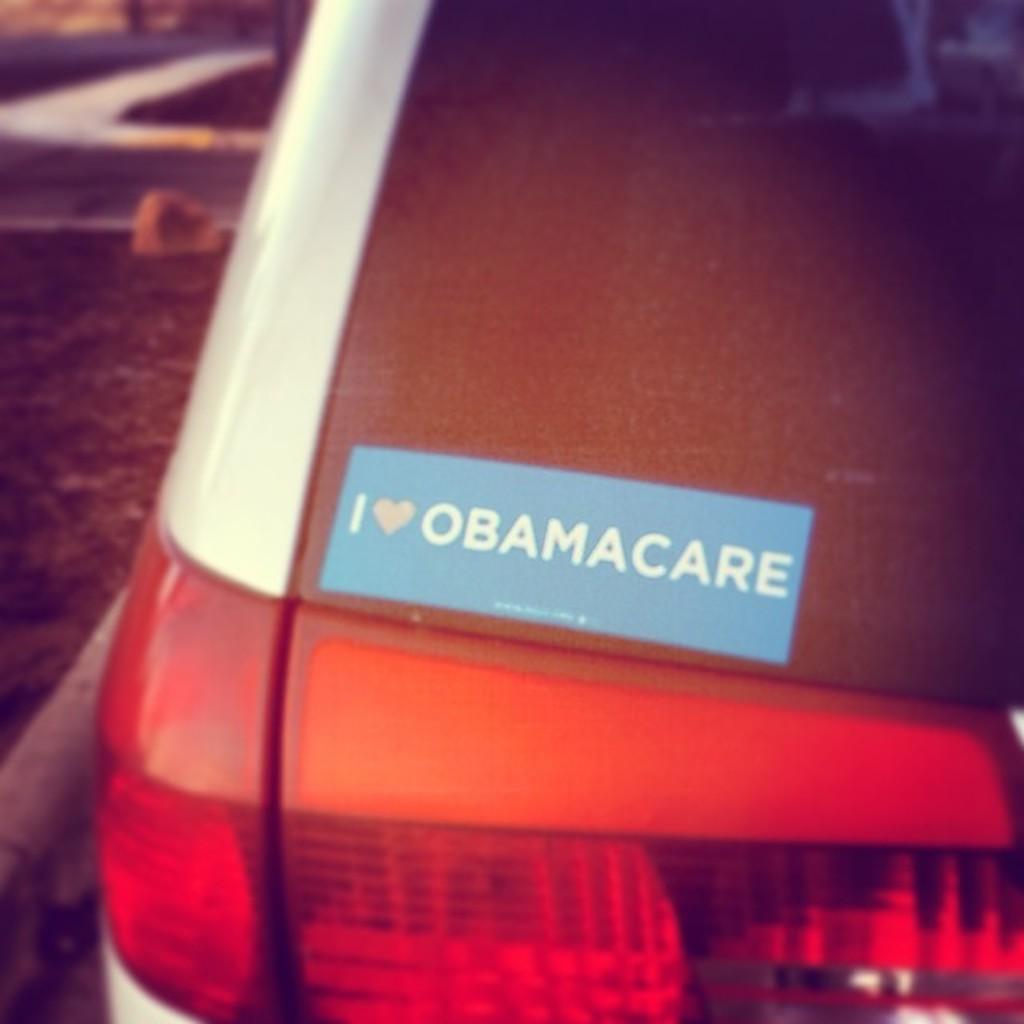How would you summarize this image in a sentence or two? In this picture we can see a vehicle and in the background we can see the road and it is blurry. 